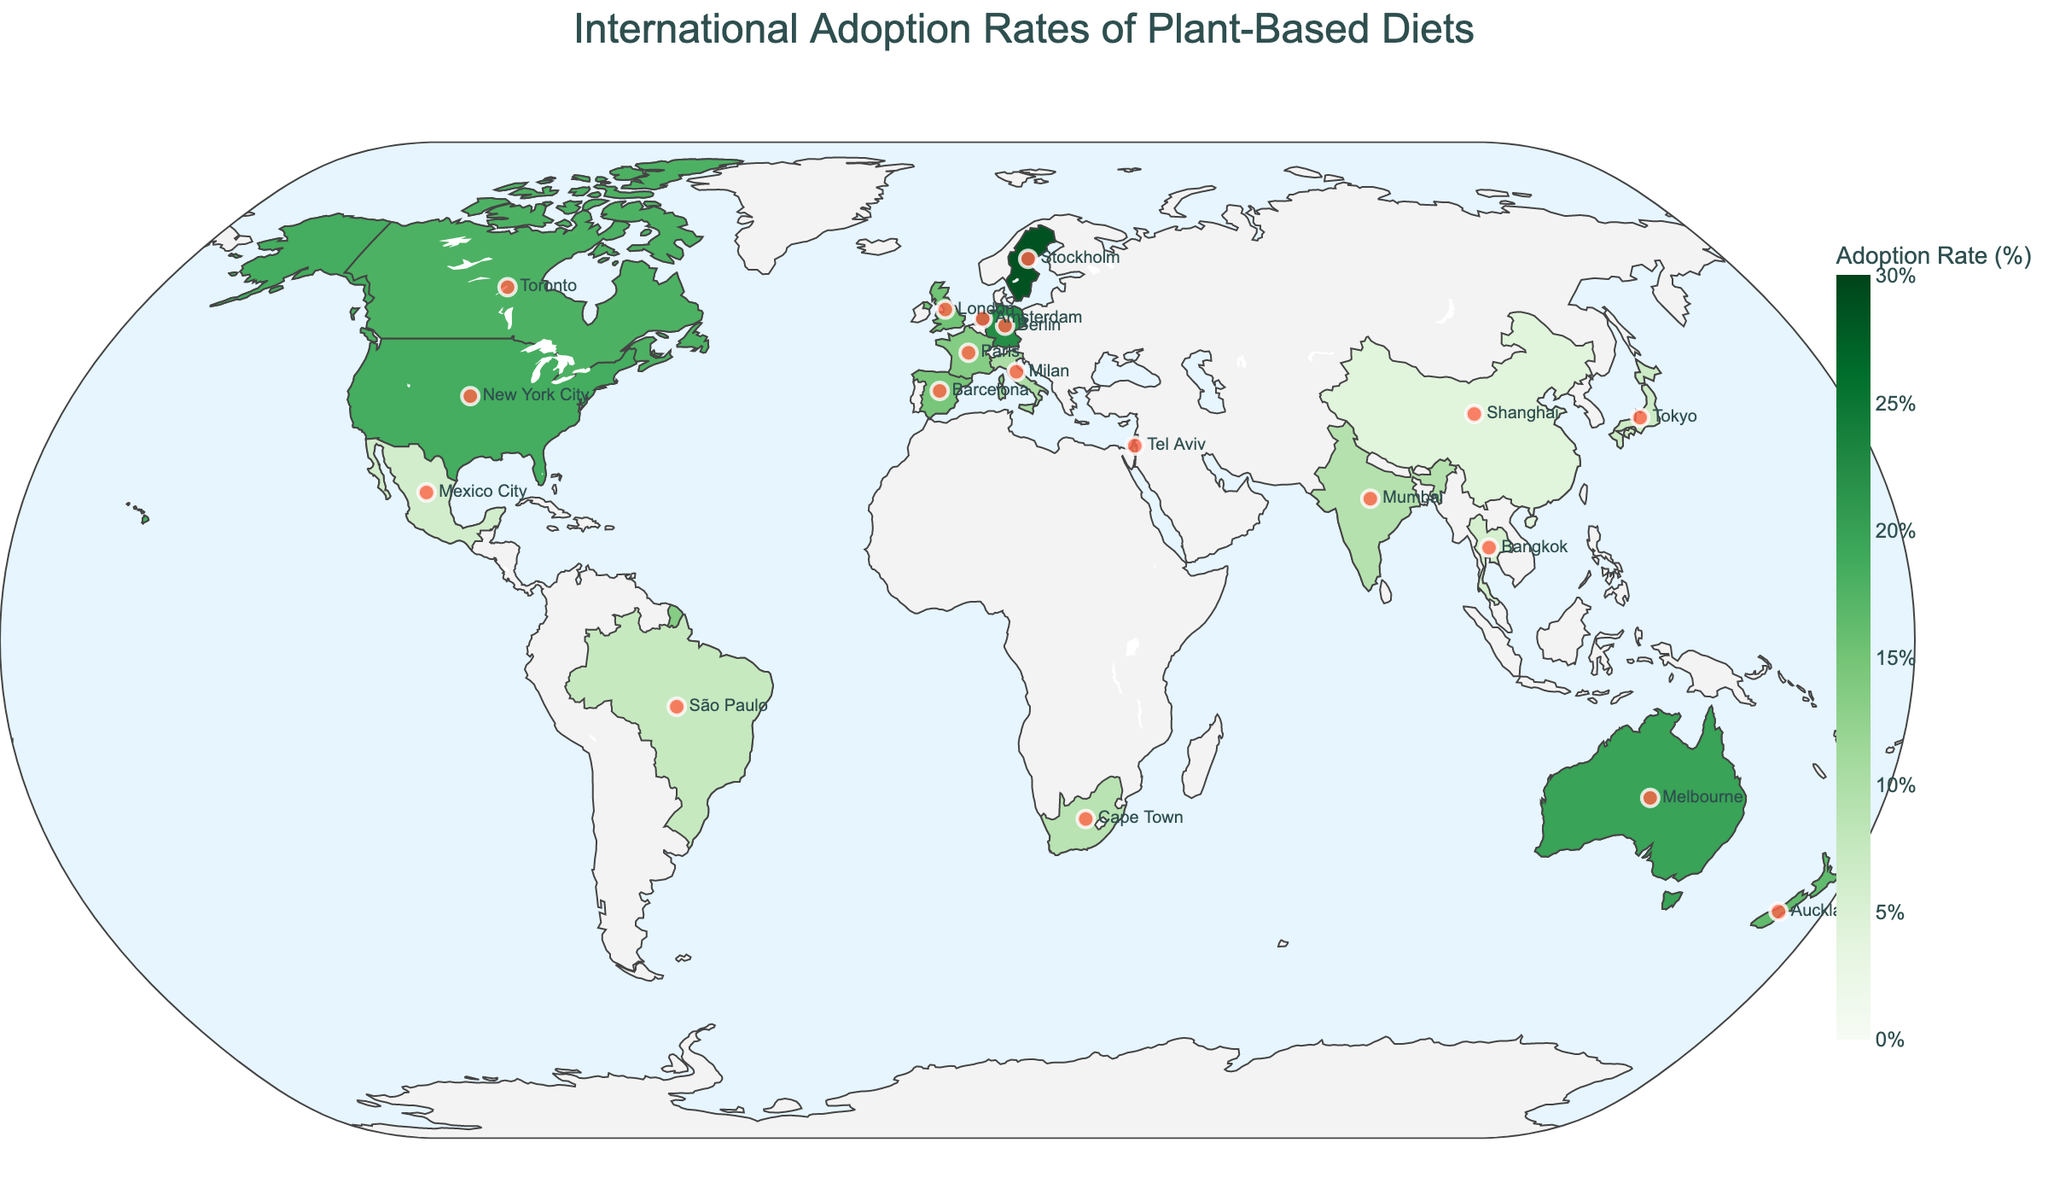Which country has the highest adoption rate of plant-based diets? The figure shows colored regions indicating adoption rates with Sweden having the darkest shade, signifying the highest adoption rate.
Answer: Sweden Which urban center in Europe has the highest adoption rate of plant-based diets? By examining the urban centers marked in Europe on the map, Stockholm, Sweden, shows the highest adoption rate as Sweden's color indicates the highest rate.
Answer: Stockholm Compare the adoption rates of plant-based diets between Tokyo and São Paulo. Which one is higher? By looking at the marker locations for Tokyo (Japan) and São Paulo (Brazil), the adoption rate in Tokyo is 6.8%, which is lower than the 7.5% rate in São Paulo.
Answer: São Paulo What is the difference in adoption rates between Berlin and Tel Aviv? Berlin has an adoption rate of 22.3%, while Tel Aviv has a rate of 13.8%. The difference is 22.3 - 13.8 = 8.5%.
Answer: 8.5% Identify one country in Asia with a lower adoption rate than Bangkok. By scanning the Asian countries and their adoption rates, Shanghai, China, has a lower adoption rate (4.2%) compared to Bangkok, Thailand (5.7%).
Answer: China Which city has the lowest adoption rate of plant-based diets? From the markers and corresponding rates, Shanghai, China, indicates the lowest adoption rate at 4.2%.
Answer: Shanghai Find the average adoption rate for the cities in North America. The figure shows New York City (18.5%), Toronto (17.9%), and Mexico City (6.1%). The average is calculated as (18.5 + 17.9 + 6.1) / 3 = 14.17%.
Answer: 14.17% Which countries have an adoption rate of plant-based diets greater than 20%? Berlin, Germany (22.3%) and Amsterdam, Netherlands (24.1%) both show regions with adoption rates over 20%.
Answer: Germany, Netherlands Are there more countries with adoption rates below 10% or above 20%? By counting, below 10%: India, Japan, Brazil, South Africa, China, Thailand, Mexico (7 countries), and above 20%: Germany, Netherlands, Sweden (3 countries). Thus, more countries are below 10%.
Answer: Below 10% Which region, Europe or Asia, generally has higher adoption rates of plant-based diets? Comparing markers, European cities (e.g., Berlin, London, Stockholm) generally have higher adoption rates than Asian cities (e.g., Tokyo, Shanghai, Bangkok).
Answer: Europe 